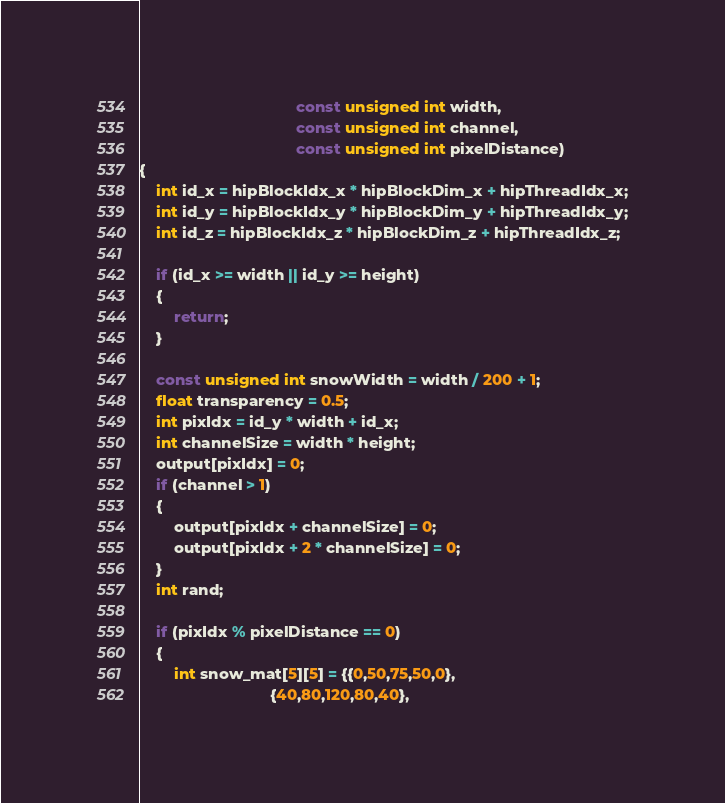Convert code to text. <code><loc_0><loc_0><loc_500><loc_500><_C++_>                                    const unsigned int width,
                                    const unsigned int channel,
                                    const unsigned int pixelDistance)
{
    int id_x = hipBlockIdx_x * hipBlockDim_x + hipThreadIdx_x;
    int id_y = hipBlockIdx_y * hipBlockDim_y + hipThreadIdx_y;
    int id_z = hipBlockIdx_z * hipBlockDim_z + hipThreadIdx_z;

    if (id_x >= width || id_y >= height)
    {
        return;
    }

    const unsigned int snowWidth = width / 200 + 1;
    float transparency = 0.5;
    int pixIdx = id_y * width + id_x;
    int channelSize = width * height;
    output[pixIdx] = 0;
    if (channel > 1)
    {
        output[pixIdx + channelSize] = 0;
        output[pixIdx + 2 * channelSize] = 0;
    }
    int rand;

    if (pixIdx % pixelDistance == 0)
    {
        int snow_mat[5][5] = {{0,50,75,50,0},
                              {40,80,120,80,40},</code> 